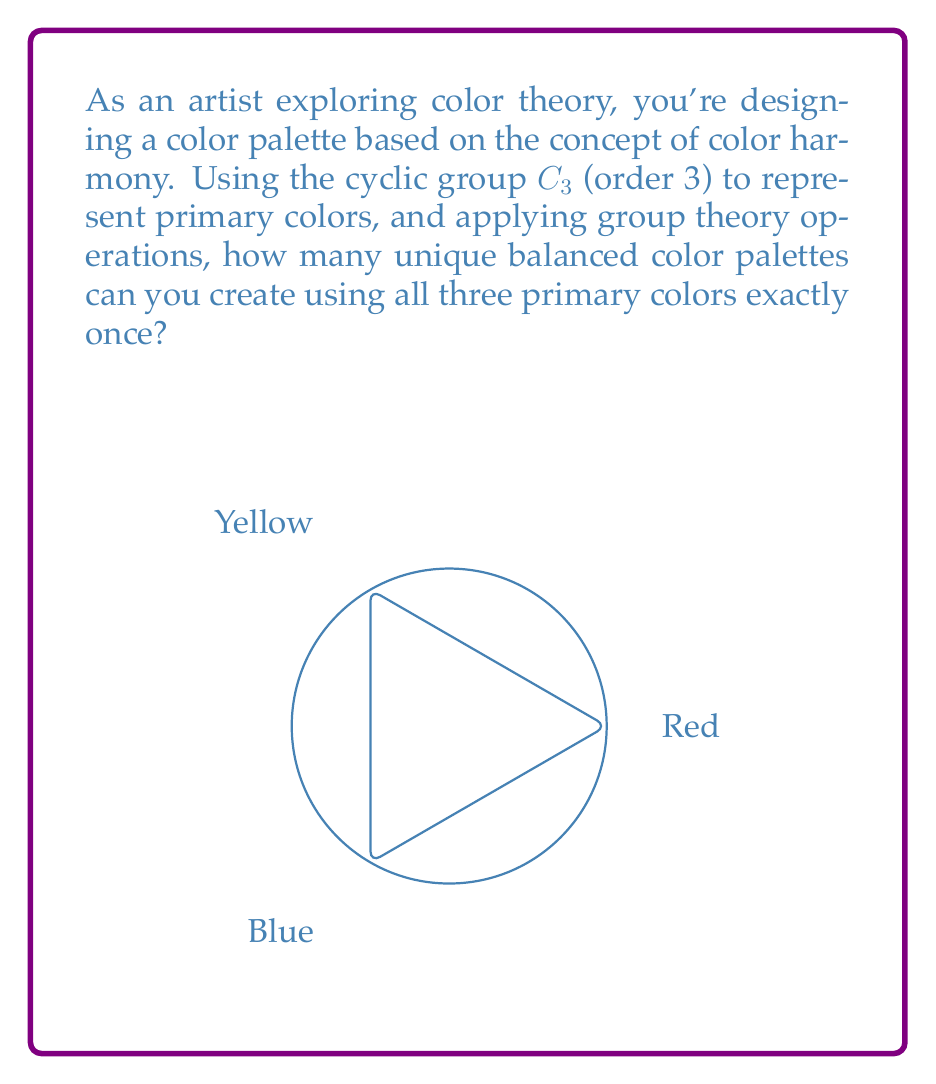What is the answer to this math problem? Let's approach this step-by-step using group theory concepts:

1) The cyclic group $C_3$ represents the three primary colors: Red (R), Blue (B), and Yellow (Y).

2) In group theory, we can represent the elements of $C_3$ as:
   $e$ (identity), $a$ (120° rotation), and $a^2$ (240° rotation)

3) We can map these to our colors:
   $e \rightarrow R$, $a \rightarrow B$, $a^2 \rightarrow Y$

4) A balanced color palette will use each color once. In group theory terms, this is equivalent to a permutation of the elements of $C_3$.

5) The number of permutations of $n$ distinct objects is given by $n!$. Here, $n = 3$.

6) Therefore, the number of possible arrangements is:

   $3! = 3 \times 2 \times 1 = 6$

7) These six arrangements correspond to the following color palettes:
   RGB, RBY, BRY, BYR, YRB, YBR

8) However, in color theory, the order of colors in a palette matters for visual balance. Each of these arrangements is considered a unique palette.

Therefore, there are 6 unique balanced color palettes using all three primary colors exactly once.
Answer: 6 